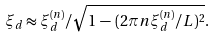<formula> <loc_0><loc_0><loc_500><loc_500>\xi _ { d } \approx \xi _ { d } ^ { ( n ) } / \sqrt { 1 \, - \, ( 2 \pi n \xi _ { d } ^ { ( n ) } / L ) ^ { 2 } } .</formula> 